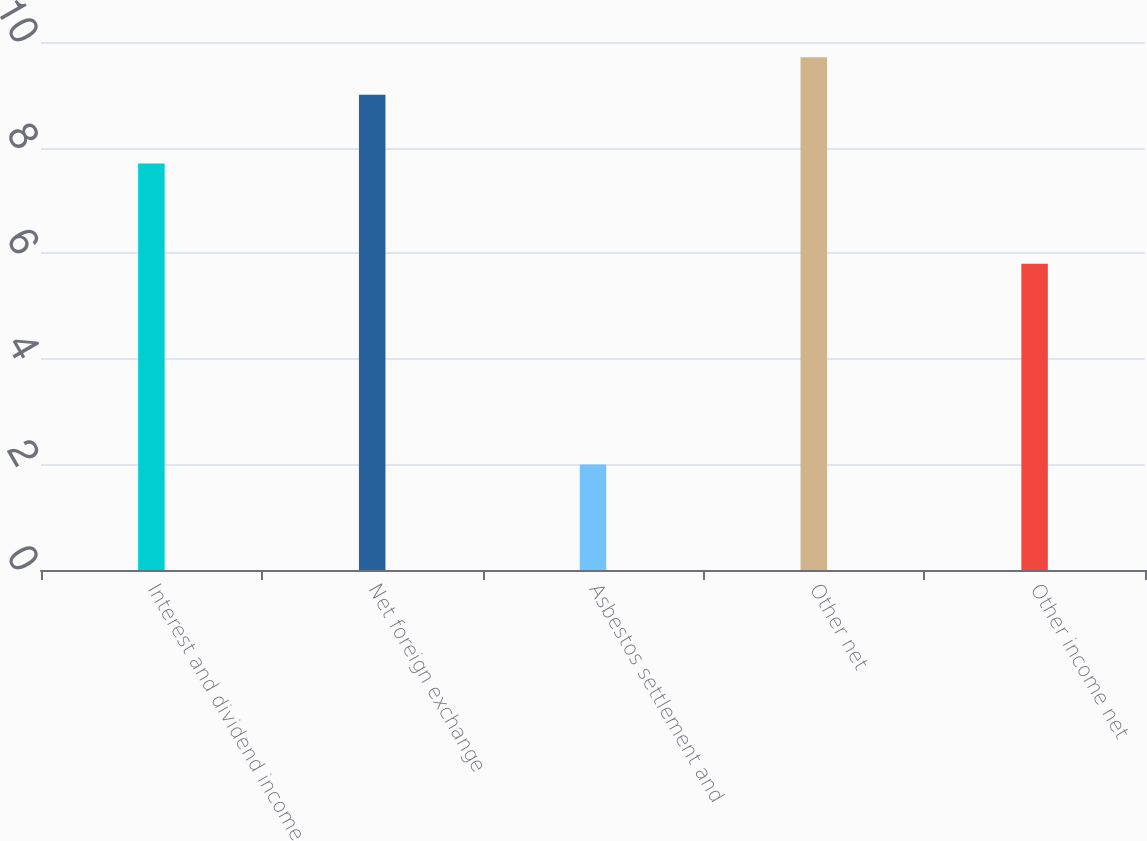Convert chart. <chart><loc_0><loc_0><loc_500><loc_500><bar_chart><fcel>Interest and dividend income<fcel>Net foreign exchange<fcel>Asbestos settlement and<fcel>Other net<fcel>Other income net<nl><fcel>7.7<fcel>9<fcel>2<fcel>9.71<fcel>5.8<nl></chart> 